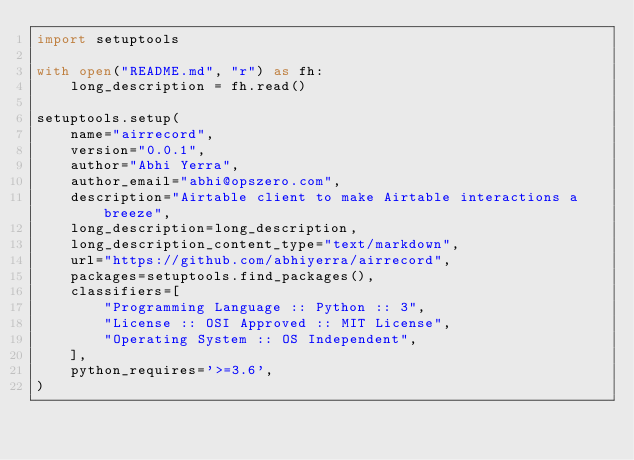<code> <loc_0><loc_0><loc_500><loc_500><_Python_>import setuptools

with open("README.md", "r") as fh:
    long_description = fh.read()

setuptools.setup(
    name="airrecord",
    version="0.0.1",
    author="Abhi Yerra",
    author_email="abhi@opszero.com",
    description="Airtable client to make Airtable interactions a breeze",
    long_description=long_description,
    long_description_content_type="text/markdown",
    url="https://github.com/abhiyerra/airrecord",
    packages=setuptools.find_packages(),
    classifiers=[
        "Programming Language :: Python :: 3",
        "License :: OSI Approved :: MIT License",
        "Operating System :: OS Independent",
    ],
    python_requires='>=3.6',
)
</code> 